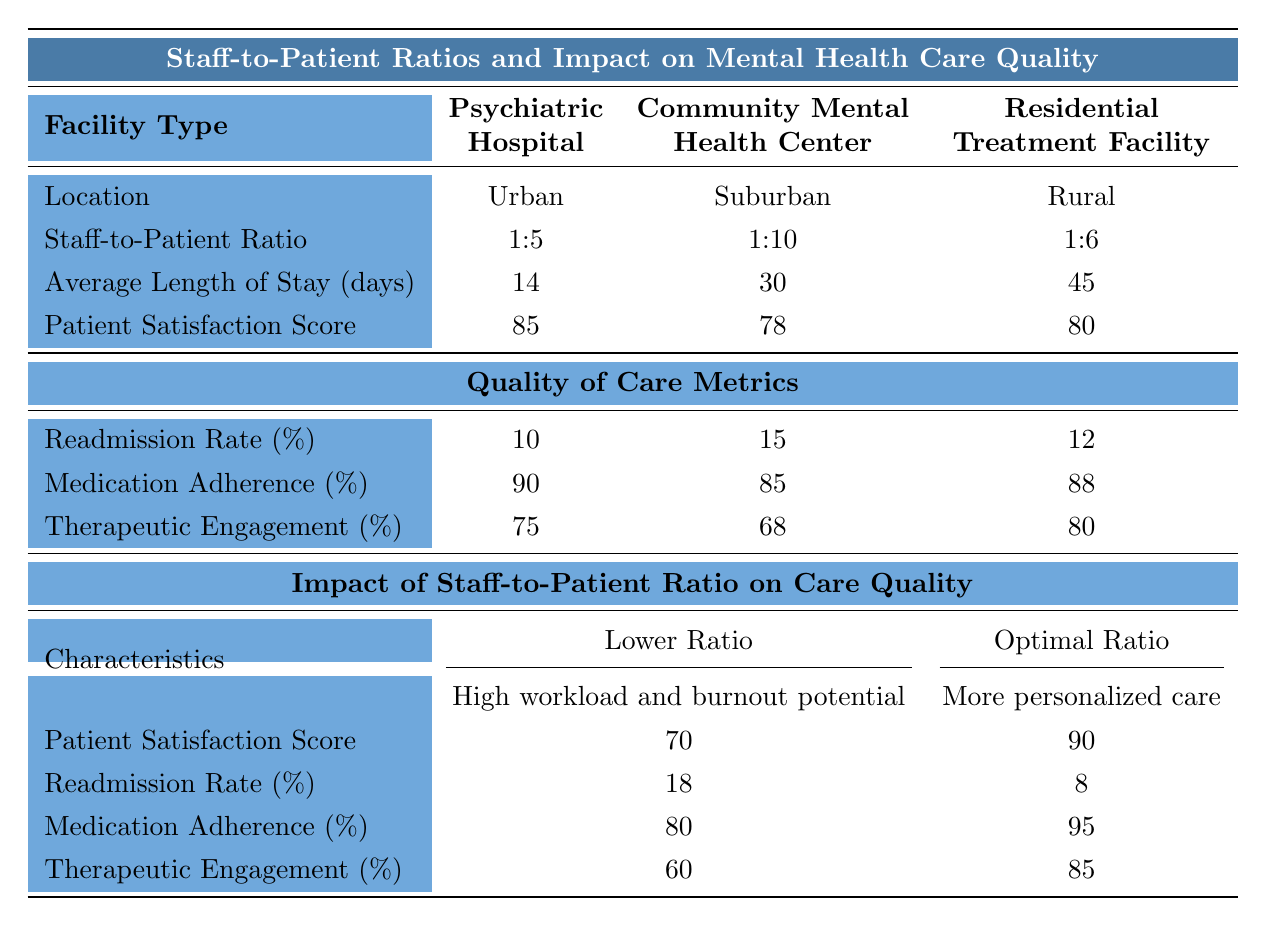What is the staff-to-patient ratio at the psychiatric hospital? The table shows that the staff-to-patient ratio for the psychiatric hospital is listed as 1:5.
Answer: 1:5 Which facility type has the highest patient satisfaction score? The table indicates that the psychiatric hospital has the highest patient satisfaction score at 85 compared to 78 for the community mental health center and 80 for the residential treatment facility.
Answer: Psychiatric hospital What is the average length of stay for patients in the residential treatment facility? According to the table, the average length of stay for patients in the residential treatment facility is 45 days.
Answer: 45 days Is the medication adherence percentage higher in community mental health centers or psychiatric hospitals? The medication adherence for community mental health centers is 85% and for psychiatric hospitals is 90%; since 90% is greater than 85%, it is higher in psychiatric hospitals.
Answer: Higher in psychiatric hospitals What is the difference in patient satisfaction scores between the optimal staff-to-patient ratio and lower staff-to-patient ratio? From the table, the patient satisfaction score for the optimal staff-to-patient ratio is 90 and for the lower ratio is 70. The difference is 90 - 70 = 20.
Answer: 20 If the average length of stay is 30 days in a community mental health center and 45 days in a residential treatment facility, what is the combined average length of stay for both facility types? To find the combined average, add the lengths of stay: 30 + 45 = 75 days, then divide by the number of facilities (2), resulting in 75/2 = 37.5 days.
Answer: 37.5 days Which facility type has the lowest readmission rate? The readmission rates are 10% for the psychiatric hospital, 15% for the community mental health center, and 12% for the residential treatment facility. Since 10% is the lowest, the psychiatric hospital has the lowest readmission rate.
Answer: Psychiatric hospital What can be inferred about the therapeutic engagement rate in facilities with higher staff-to-patient ratios? The table shows that as the staff-to-patient ratio increases (e.g., 1:10 in community mental health centers), the therapeutic engagement rate tends to decrease (68% for community mental health center) compared to 75% for psychiatric hospital (1:5). Thus, higher ratios may correlate to lower engagement.
Answer: Lower engagement How does the readmission rate in the optimal staff-to-patient ratio compare to that in the lower staff-to-patient ratio? The readmission rate for the optimal staff-to-patient ratio is 8%, while for the lower staff-to-patient ratio it is 18%. The optimal ratio has a significantly lower readmission rate.
Answer: Lower in optimal ratio Can we conclude that rural facilities have better patient satisfaction than suburban facilities? The table lists patient satisfaction at 80% for the residential treatment facility (rural) and 78% for the community mental health center (suburban). Since 80% is greater than 78%, we can conclude that rural facilities have better patient satisfaction.
Answer: Yes 